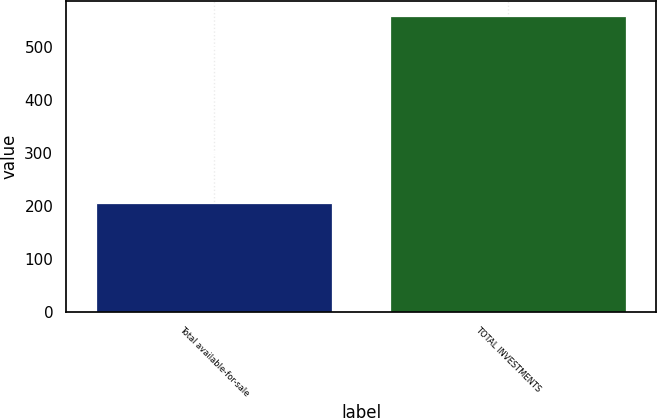<chart> <loc_0><loc_0><loc_500><loc_500><bar_chart><fcel>Total available-for-sale<fcel>TOTAL INVESTMENTS<nl><fcel>206<fcel>559<nl></chart> 